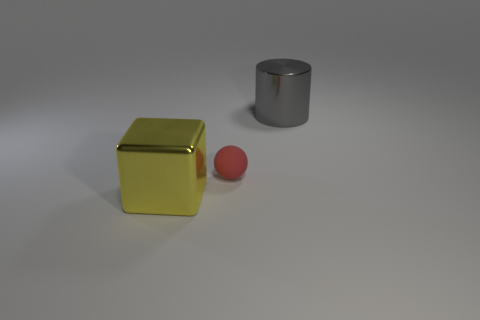Add 2 gray blocks. How many objects exist? 5 Subtract all spheres. How many objects are left? 2 Add 1 yellow metal things. How many yellow metal things are left? 2 Add 2 matte things. How many matte things exist? 3 Subtract 0 cyan cubes. How many objects are left? 3 Subtract all red matte things. Subtract all big yellow objects. How many objects are left? 1 